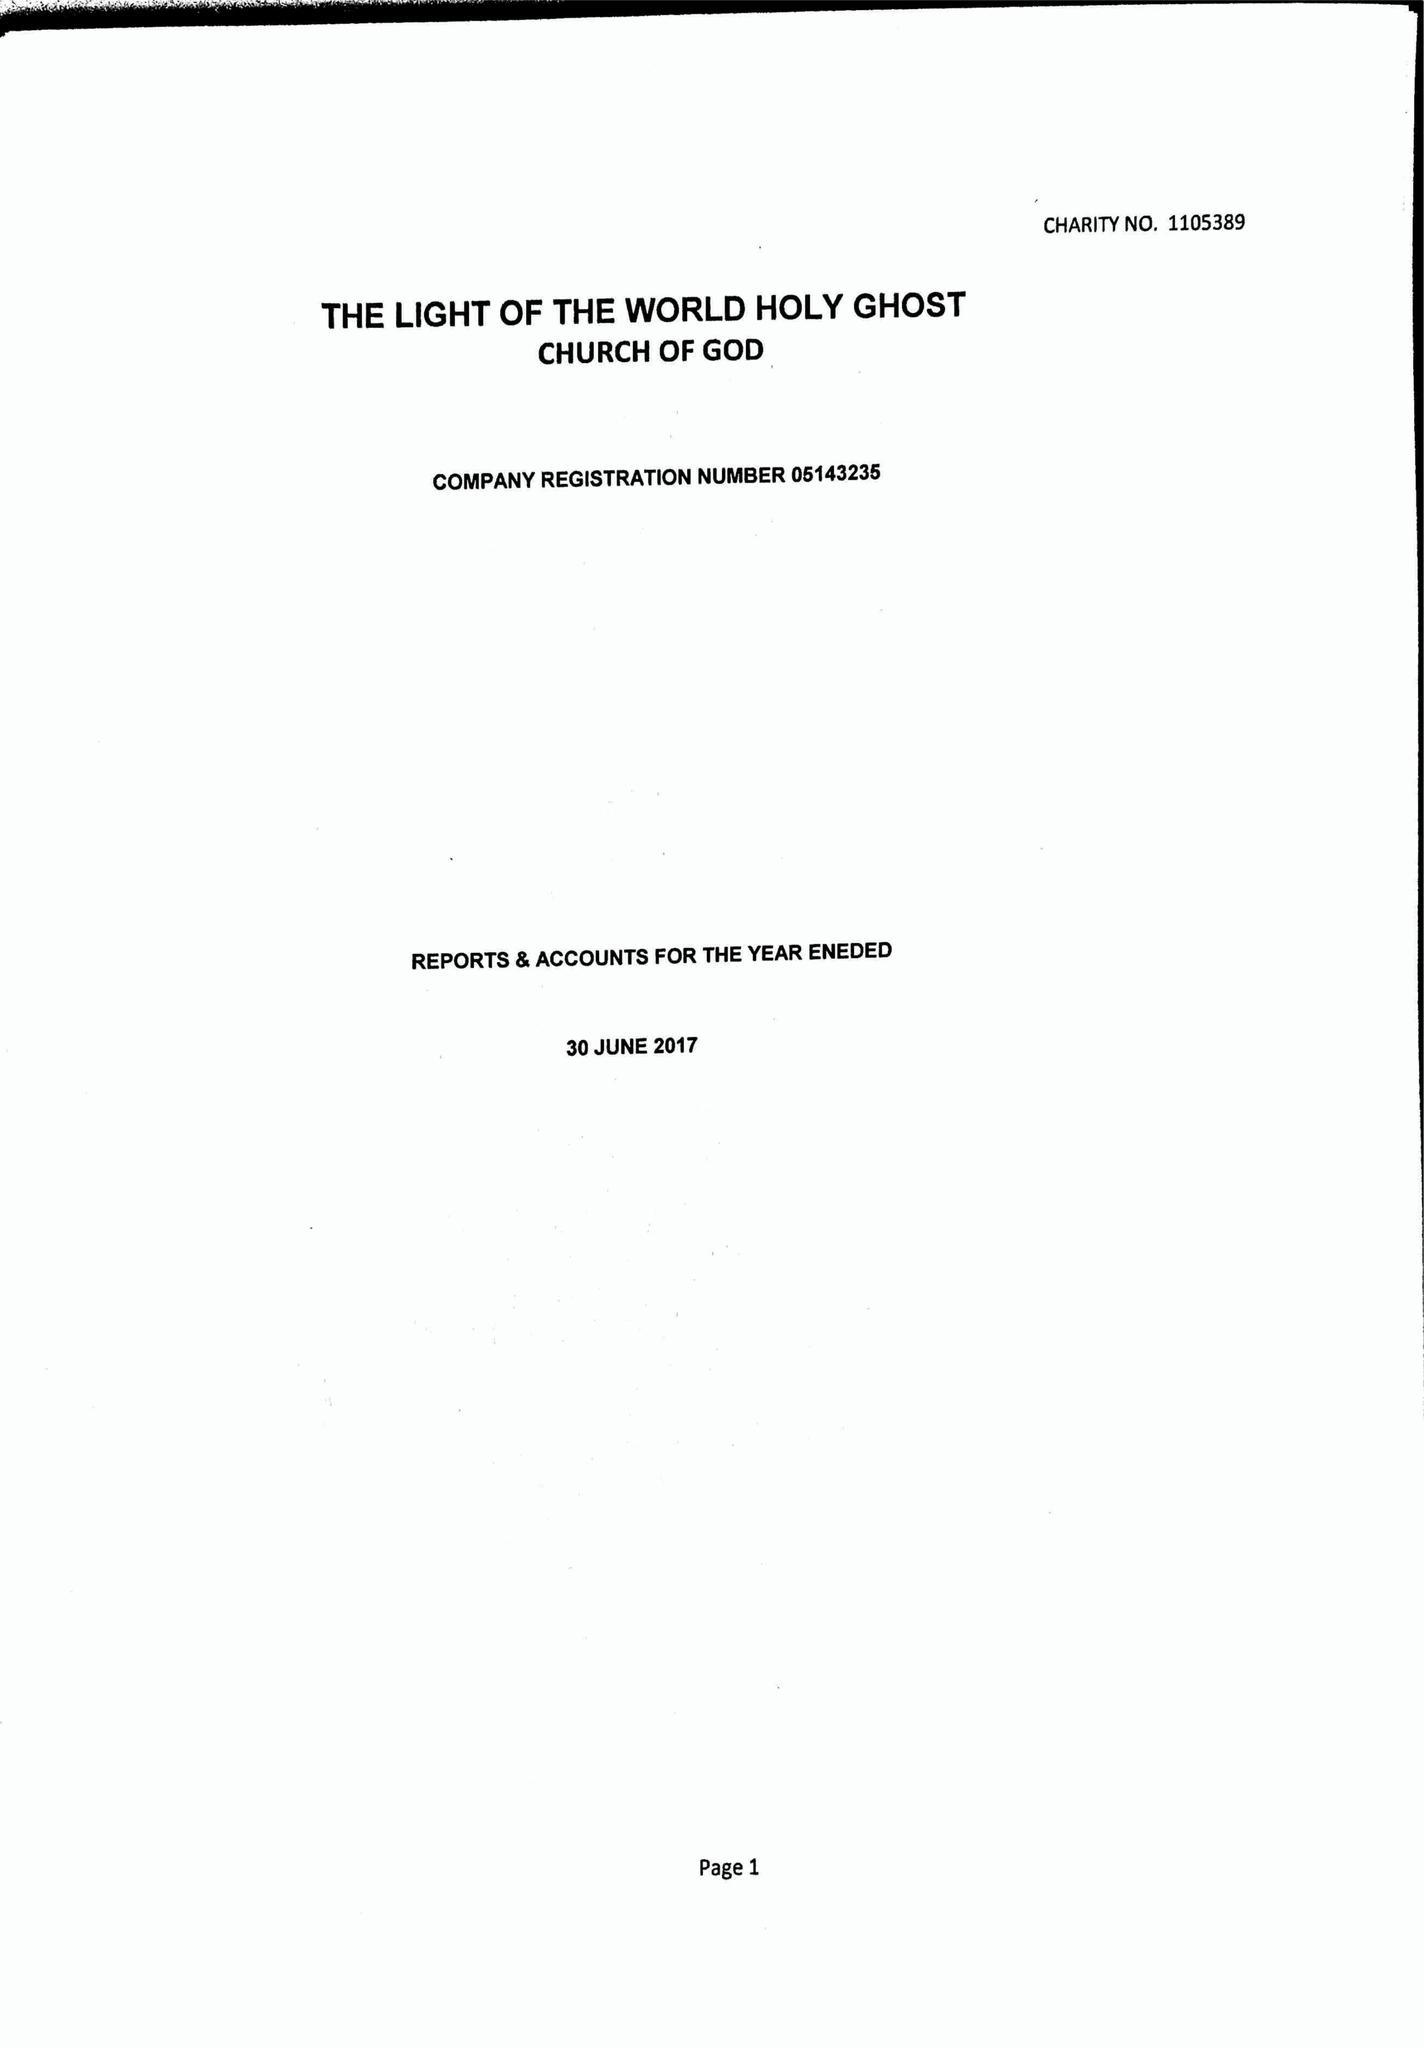What is the value for the address__postcode?
Answer the question using a single word or phrase. DA11 9QG 